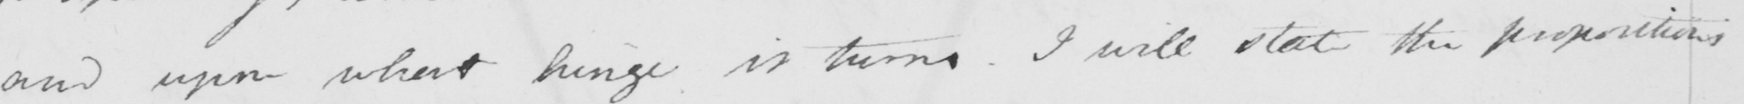Please provide the text content of this handwritten line. and upon what hinge it turns . I will state the propositions 